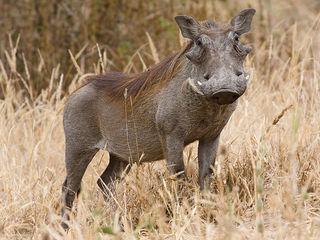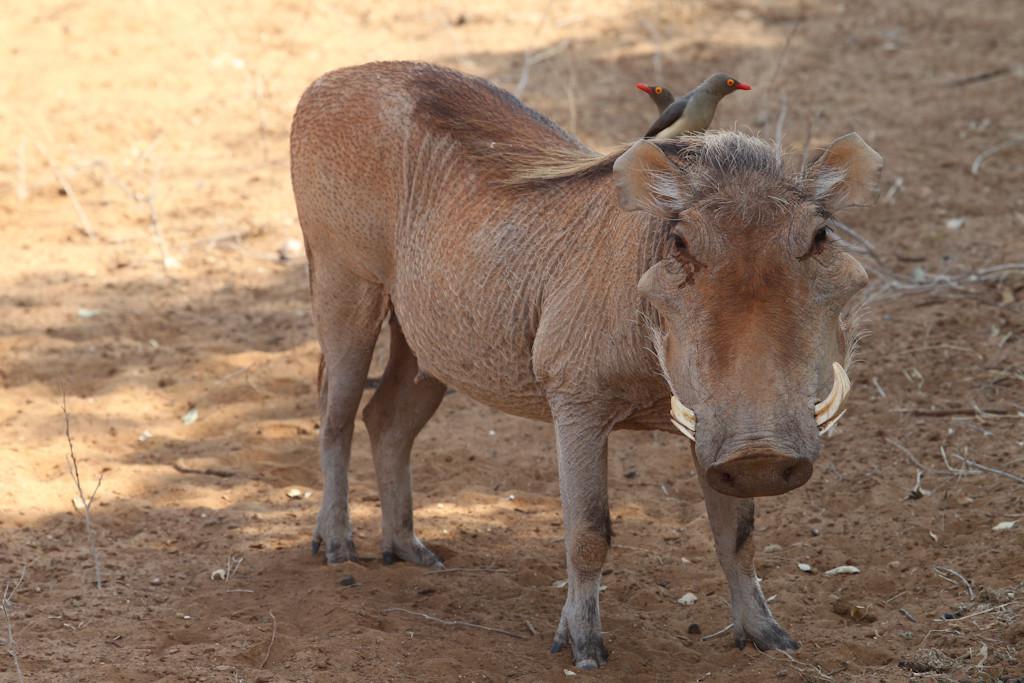The first image is the image on the left, the second image is the image on the right. Considering the images on both sides, is "One image includes at least one bird with a standing warthog." valid? Answer yes or no. Yes. 